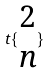<formula> <loc_0><loc_0><loc_500><loc_500>t \{ \begin{matrix} 2 \\ n \end{matrix} \}</formula> 